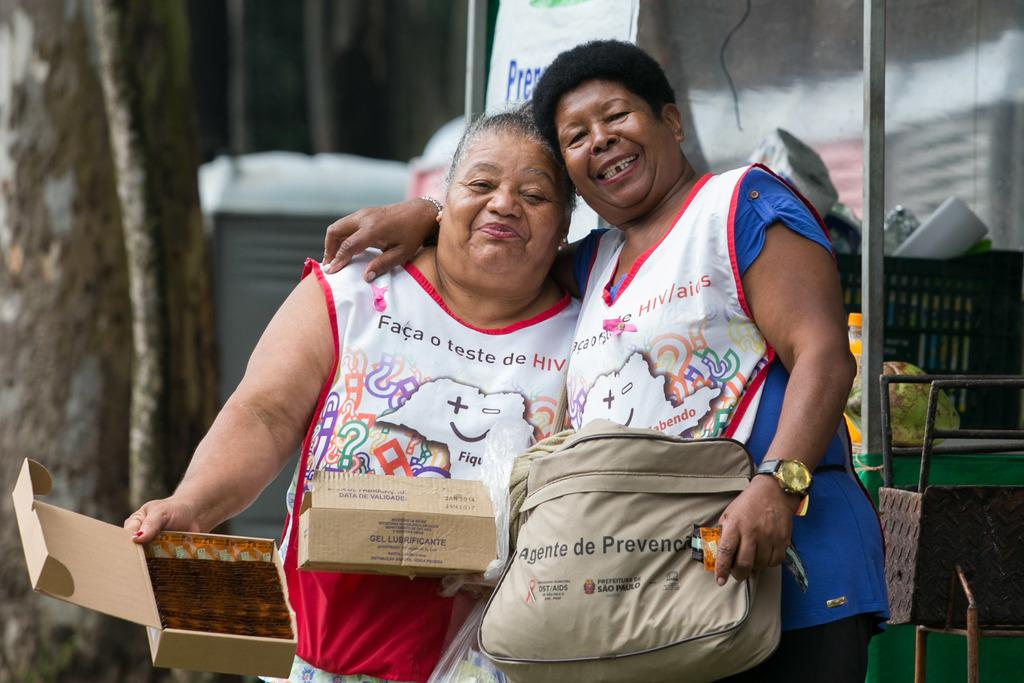<image>
Provide a brief description of the given image. A woman with a handbag that says Agente de Prevenca. 